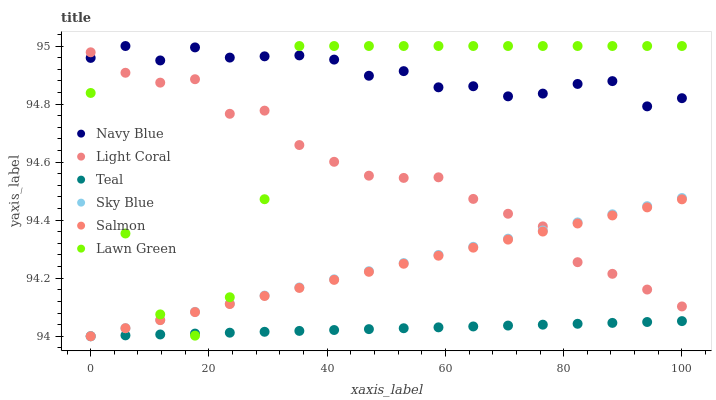Does Teal have the minimum area under the curve?
Answer yes or no. Yes. Does Navy Blue have the maximum area under the curve?
Answer yes or no. Yes. Does Salmon have the minimum area under the curve?
Answer yes or no. No. Does Salmon have the maximum area under the curve?
Answer yes or no. No. Is Salmon the smoothest?
Answer yes or no. Yes. Is Lawn Green the roughest?
Answer yes or no. Yes. Is Navy Blue the smoothest?
Answer yes or no. No. Is Navy Blue the roughest?
Answer yes or no. No. Does Salmon have the lowest value?
Answer yes or no. Yes. Does Navy Blue have the lowest value?
Answer yes or no. No. Does Navy Blue have the highest value?
Answer yes or no. Yes. Does Salmon have the highest value?
Answer yes or no. No. Is Sky Blue less than Navy Blue?
Answer yes or no. Yes. Is Navy Blue greater than Sky Blue?
Answer yes or no. Yes. Does Light Coral intersect Salmon?
Answer yes or no. Yes. Is Light Coral less than Salmon?
Answer yes or no. No. Is Light Coral greater than Salmon?
Answer yes or no. No. Does Sky Blue intersect Navy Blue?
Answer yes or no. No. 